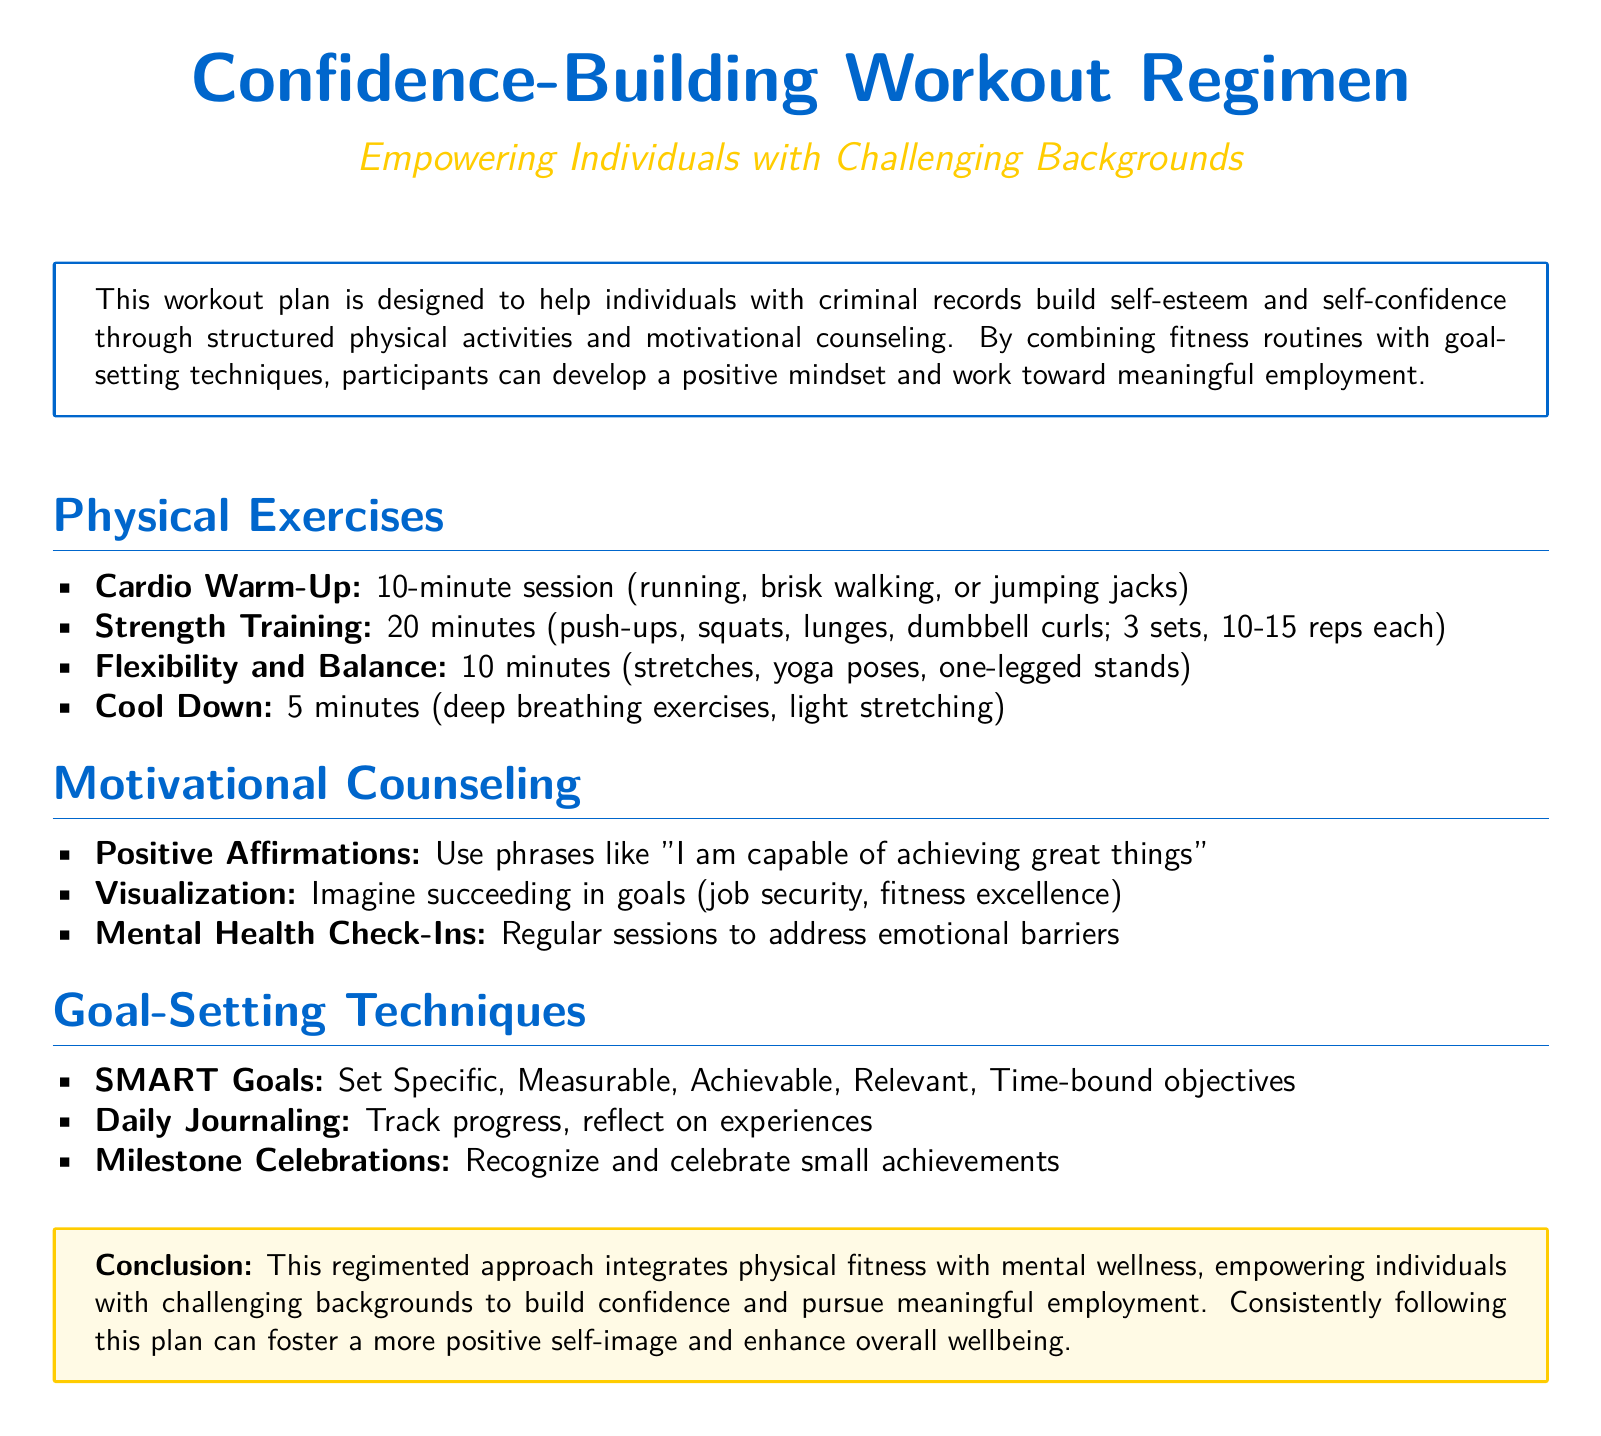What is the duration of the cardio warm-up? The cardio warm-up is specified to be a 10-minute session.
Answer: 10 minutes How many sets are recommended for strength training? The workout plan recommends 3 sets for strength training exercises.
Answer: 3 sets What is one of the techniques listed in the motivational counseling section? The motivational counseling section includes various techniques, one being "Positive affirmations".
Answer: Positive affirmations Which fitness routine focuses on flexibility and balance? The section outlines "Flexibility and Balance" exercises such as stretches and yoga poses.
Answer: Flexibility and Balance What does SMART stand for in goal-setting techniques? SMART is an acronym for Specific, Measurable, Achievable, Relevant, Time-bound.
Answer: Specific, Measurable, Achievable, Relevant, Time-bound What exercise is part of the strength training regimen? The strength training includes exercises like push-ups and squats.
Answer: Push-ups What is the main purpose of this workout plan? The workout plan is designed to help individuals with criminal records build self-esteem and self-confidence.
Answer: Build self-esteem and self-confidence How long should the cool down session last? The cool down session is specified to last for 5 minutes.
Answer: 5 minutes 